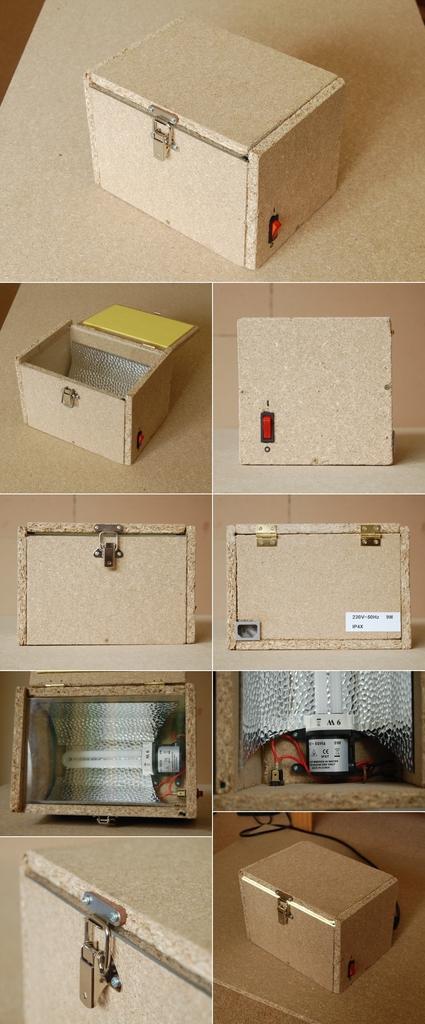How would you summarize this image in a sentence or two? In this image I can see a collage picture, I can also see a box in cream color and I can also see few light and a curtain in cream color. 